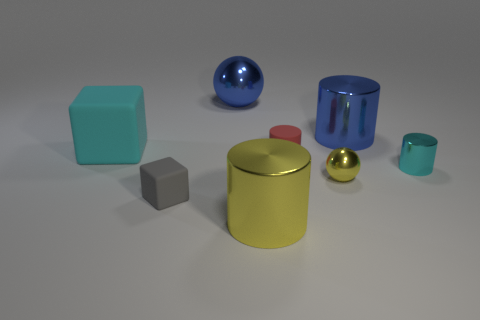Subtract 1 cylinders. How many cylinders are left? 3 Add 1 blue cylinders. How many objects exist? 9 Subtract all balls. How many objects are left? 6 Add 2 yellow metallic things. How many yellow metallic things exist? 4 Subtract 0 blue cubes. How many objects are left? 8 Subtract all big gray cylinders. Subtract all large blue shiny cylinders. How many objects are left? 7 Add 3 blue shiny objects. How many blue shiny objects are left? 5 